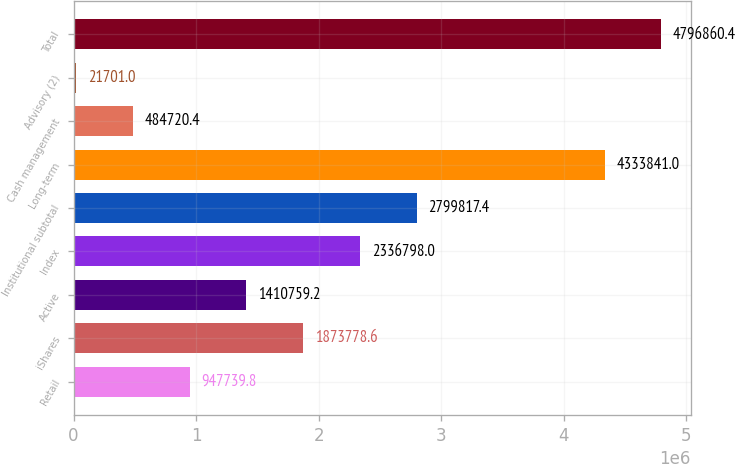Convert chart to OTSL. <chart><loc_0><loc_0><loc_500><loc_500><bar_chart><fcel>Retail<fcel>iShares<fcel>Active<fcel>Index<fcel>Institutional subtotal<fcel>Long-term<fcel>Cash management<fcel>Advisory (2)<fcel>Total<nl><fcel>947740<fcel>1.87378e+06<fcel>1.41076e+06<fcel>2.3368e+06<fcel>2.79982e+06<fcel>4.33384e+06<fcel>484720<fcel>21701<fcel>4.79686e+06<nl></chart> 